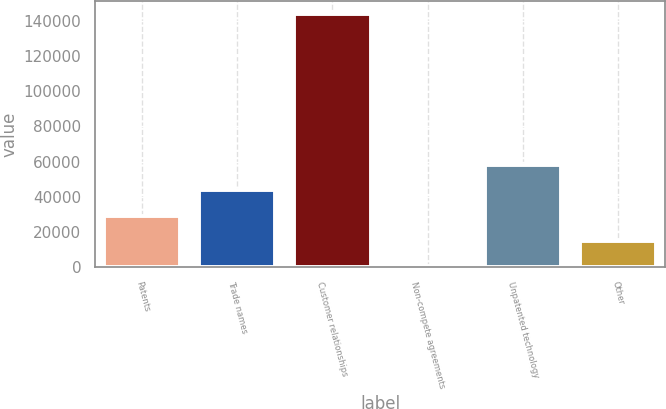Convert chart to OTSL. <chart><loc_0><loc_0><loc_500><loc_500><bar_chart><fcel>Patents<fcel>Trade names<fcel>Customer relationships<fcel>Non-compete agreements<fcel>Unpatented technology<fcel>Other<nl><fcel>29446.8<fcel>43782.7<fcel>144134<fcel>775<fcel>58118.6<fcel>15110.9<nl></chart> 